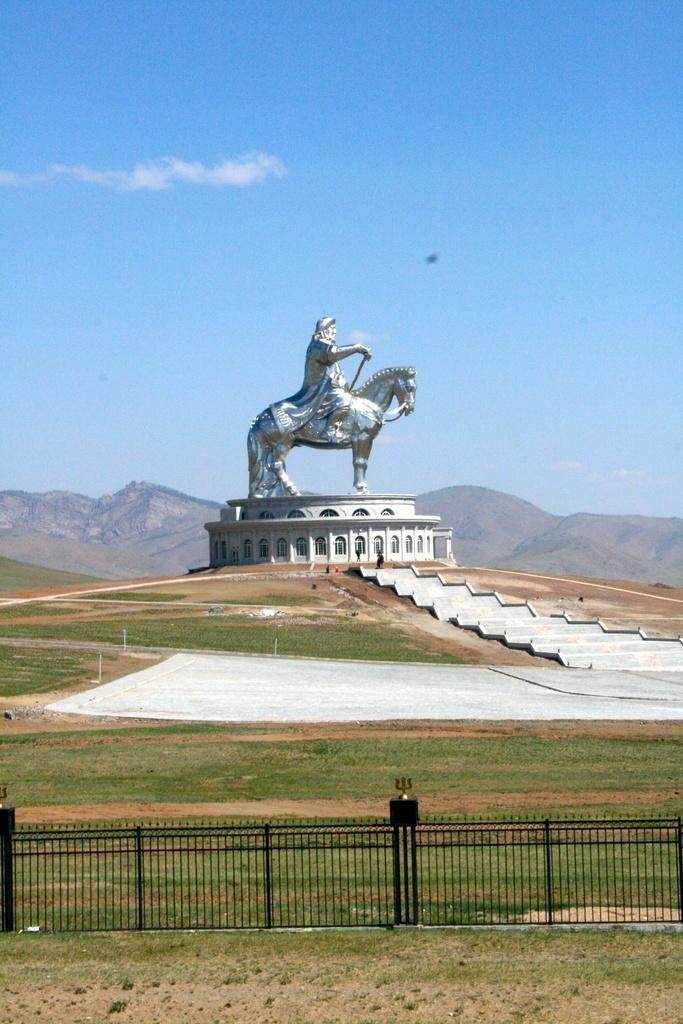What is the main subject of the image? There is a sculpture in the image. What type of natural environment is visible in the image? There is grass in the image. What type of barrier is present in the image? There is a fence in the image. What can be seen in the background of the image? There is a mountain and the sky visible in the background of the image. What type of paper is being used to create the sculpture in the image? There is no paper mentioned or visible in the image; the sculpture is not made of paper. Can you see any yams growing in the grass in the image? There are no yams visible in the image; the focus is on the sculpture and the surrounding environment. 